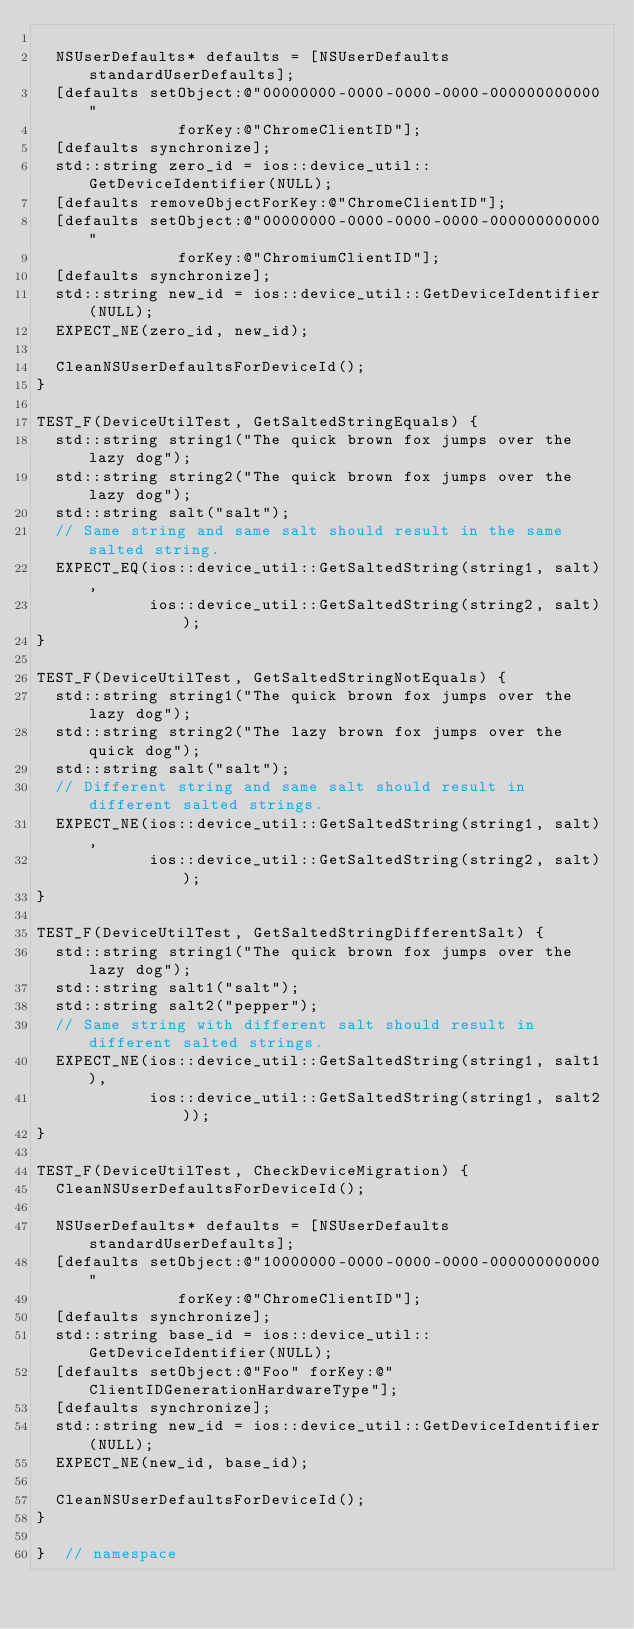Convert code to text. <code><loc_0><loc_0><loc_500><loc_500><_ObjectiveC_>
  NSUserDefaults* defaults = [NSUserDefaults standardUserDefaults];
  [defaults setObject:@"00000000-0000-0000-0000-000000000000"
               forKey:@"ChromeClientID"];
  [defaults synchronize];
  std::string zero_id = ios::device_util::GetDeviceIdentifier(NULL);
  [defaults removeObjectForKey:@"ChromeClientID"];
  [defaults setObject:@"00000000-0000-0000-0000-000000000000"
               forKey:@"ChromiumClientID"];
  [defaults synchronize];
  std::string new_id = ios::device_util::GetDeviceIdentifier(NULL);
  EXPECT_NE(zero_id, new_id);

  CleanNSUserDefaultsForDeviceId();
}

TEST_F(DeviceUtilTest, GetSaltedStringEquals) {
  std::string string1("The quick brown fox jumps over the lazy dog");
  std::string string2("The quick brown fox jumps over the lazy dog");
  std::string salt("salt");
  // Same string and same salt should result in the same salted string.
  EXPECT_EQ(ios::device_util::GetSaltedString(string1, salt),
            ios::device_util::GetSaltedString(string2, salt));
}

TEST_F(DeviceUtilTest, GetSaltedStringNotEquals) {
  std::string string1("The quick brown fox jumps over the lazy dog");
  std::string string2("The lazy brown fox jumps over the quick dog");
  std::string salt("salt");
  // Different string and same salt should result in different salted strings.
  EXPECT_NE(ios::device_util::GetSaltedString(string1, salt),
            ios::device_util::GetSaltedString(string2, salt));
}

TEST_F(DeviceUtilTest, GetSaltedStringDifferentSalt) {
  std::string string1("The quick brown fox jumps over the lazy dog");
  std::string salt1("salt");
  std::string salt2("pepper");
  // Same string with different salt should result in different salted strings.
  EXPECT_NE(ios::device_util::GetSaltedString(string1, salt1),
            ios::device_util::GetSaltedString(string1, salt2));
}

TEST_F(DeviceUtilTest, CheckDeviceMigration) {
  CleanNSUserDefaultsForDeviceId();

  NSUserDefaults* defaults = [NSUserDefaults standardUserDefaults];
  [defaults setObject:@"10000000-0000-0000-0000-000000000000"
               forKey:@"ChromeClientID"];
  [defaults synchronize];
  std::string base_id = ios::device_util::GetDeviceIdentifier(NULL);
  [defaults setObject:@"Foo" forKey:@"ClientIDGenerationHardwareType"];
  [defaults synchronize];
  std::string new_id = ios::device_util::GetDeviceIdentifier(NULL);
  EXPECT_NE(new_id, base_id);

  CleanNSUserDefaultsForDeviceId();
}

}  // namespace
</code> 